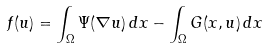<formula> <loc_0><loc_0><loc_500><loc_500>f ( u ) = \int _ { \Omega } \Psi ( \nabla u ) \, d x - \int _ { \Omega } G ( x , u ) \, d x</formula> 